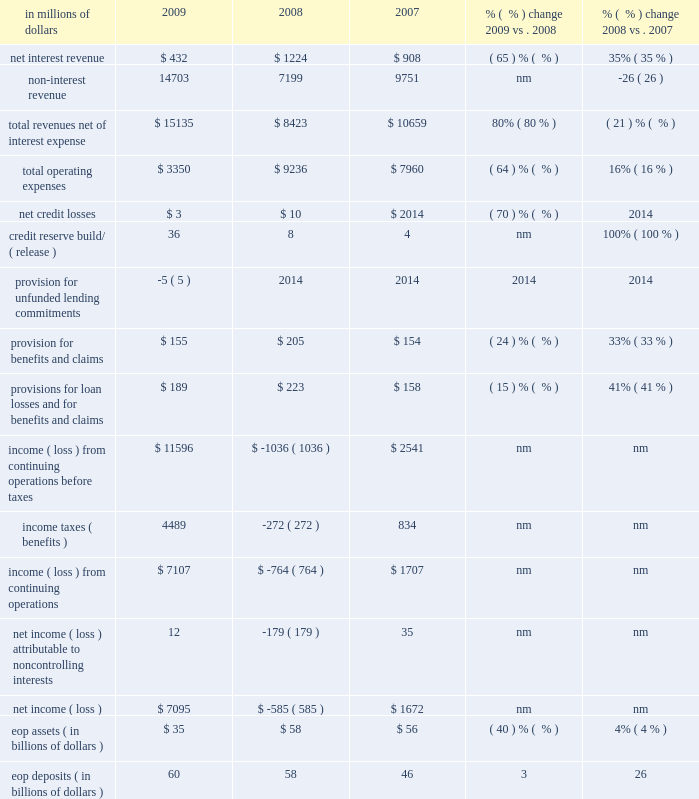Brokerage and asset management brokerage and asset management ( bam ) , which constituted approximately 6% ( 6 % ) of citi holdings by assets as of december 31 , 2009 , consists of citi 2019s global retail brokerage and asset management businesses .
This segment was substantially affected and reduced in size in 2009 due to the divestitures of smith barney ( to the morgan stanley smith barney joint venture ( mssb jv ) ) and nikko cordial securities .
At december 31 , 2009 , bam had approximately $ 35 billion of assets , which included $ 26 billion of assets from the 49% ( 49 % ) interest in the mssb jv ( $ 13 billion investment and $ 13 billion in loans associated with the clients of the mssb jv ) and $ 9 billion of assets from a diverse set of asset management and insurance businesses of which approximately half will be transferred into the latam rcb during the first quarter of 2010 , as discussed under 201cciti holdings 201d above .
Morgan stanley has options to purchase citi 2019s remaining stake in the mssb jv over three years starting in 2012 .
The 2009 results include an $ 11.1 billion gain ( $ 6.7 billion after-tax ) on the sale of smith barney .
In millions of dollars 2009 2008 2007 % (  % ) change 2009 vs .
2008 % (  % ) change 2008 vs .
2007 .
Nm not meaningful 2009 vs .
2008 revenues , net of interest expense increased 80% ( 80 % ) versus the prior year mainly driven by the $ 11.1 billion pretax gain on the sale ( $ 6.7 billion after-tax ) on the mssb jv transaction in the second quarter of 2009 and a $ 320 million pretax gain on the sale of the managed futures business to the mssb jv in the third quarter of 2009 .
Excluding these gains , revenue decreased primarily due to the absence of smith barney from may 2009 onwards and the absence of fourth-quarter revenue of nikko asset management , partially offset by an improvement in marks in retail alternative investments .
Revenues in the prior year include a $ 347 million pretax gain on sale of citistreet and charges related to the settlement of auction rate securities of $ 393 million pretax .
Operating expenses decreased 64% ( 64 % ) from the prior year , mainly driven by the absence of smith barney and nikko asset management expenses , re- engineering efforts and the absence of 2008 one-time expenses ( $ 0.9 billion intangible impairment , $ 0.2 billion of restructuring and $ 0.5 billion of write- downs and other charges ) .
Provisions for loan losses and for benefits and claims decreased 15% ( 15 % ) mainly reflecting a $ 50 million decrease in provision for benefits and claims , partially offset by increased reserve builds of $ 28 million .
Assets decreased 40% ( 40 % ) versus the prior year , mostly driven by the sales of nikko cordial securities and nikko asset management ( $ 25 billion ) and the managed futures business ( $ 1.4 billion ) , partially offset by increased smith barney assets of $ 4 billion .
2008 vs .
2007 revenues , net of interest expense decreased 21% ( 21 % ) from the prior year primarily due to lower transactional and investment revenues in smith barney , lower revenues in nikko asset management and higher markdowns in retail alternative investments .
Operating expenses increased 16% ( 16 % ) versus the prior year , mainly driven by a $ 0.9 billion intangible impairment in nikko asset management in the fourth quarter of 2008 , $ 0.2 billion of restructuring charges and $ 0.5 billion of write-downs and other charges .
Provisions for loan losses and for benefits and claims increased $ 65 million compared to the prior year , mainly due to a $ 52 million increase in provisions for benefits and claims .
Assets increased 4% ( 4 % ) versus the prior year. .
As a percent of total revenues net of interest expense what was non-interest revenue in 2007? 
Computations: (9751 / 10659)
Answer: 0.91481. 